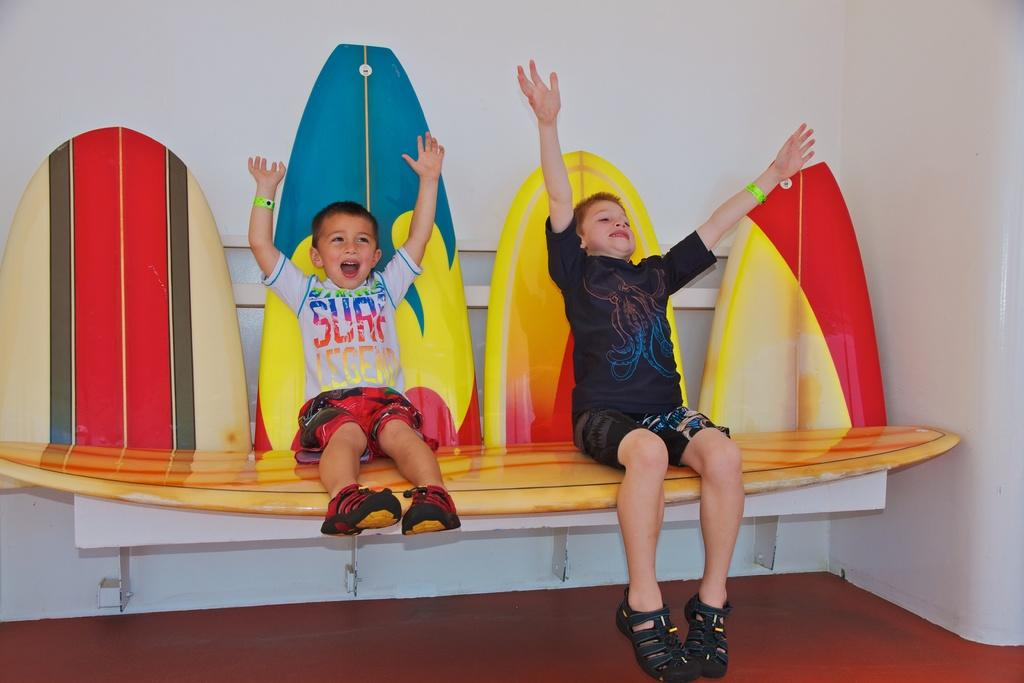How many people are in the image? There are two boys in the image. What are the boys doing in the image? The boys are sitting on skateboards. What can be seen in the background of the image? There is a wall in the background of the image. What is at the bottom of the image? There is a floor at the bottom of the image. What type of grape is being used as a prop in the image? There is no grape present in the image. What is the boys' occupation, as depicted in the image? The image does not depict the boys' occupation; it only shows them sitting on skateboards. 